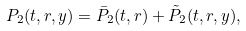<formula> <loc_0><loc_0><loc_500><loc_500>P _ { 2 } ( t , r , y ) = \bar { P } _ { 2 } ( t , r ) + \tilde { P } _ { 2 } ( t , r , y ) ,</formula> 